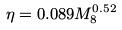Convert formula to latex. <formula><loc_0><loc_0><loc_500><loc_500>\eta = 0 . 0 8 9 M _ { 8 } ^ { 0 . 5 2 }</formula> 